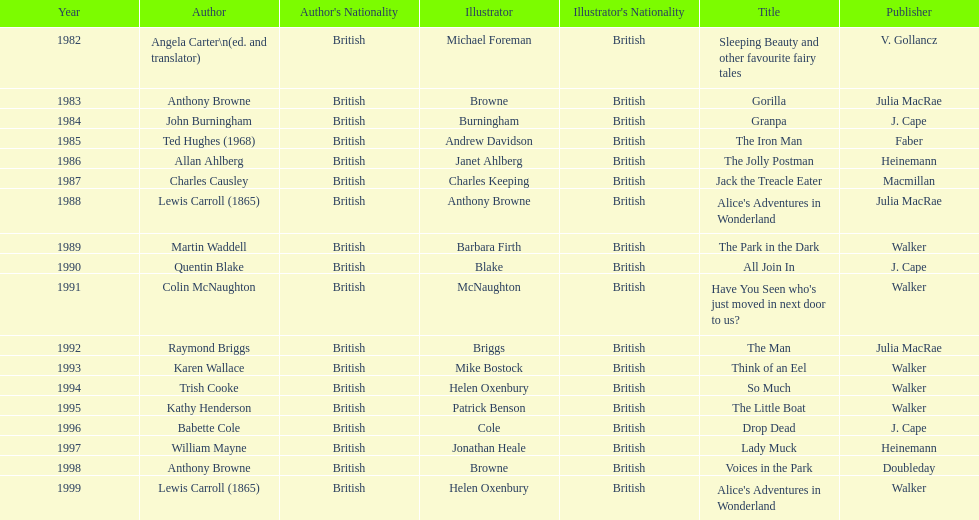What is the difference in years between the publication of angela carter's and anthony browne's titles? 1. 